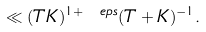<formula> <loc_0><loc_0><loc_500><loc_500>\ll ( T K ) ^ { 1 + \ e p s } ( T + K ) ^ { - 1 } .</formula> 